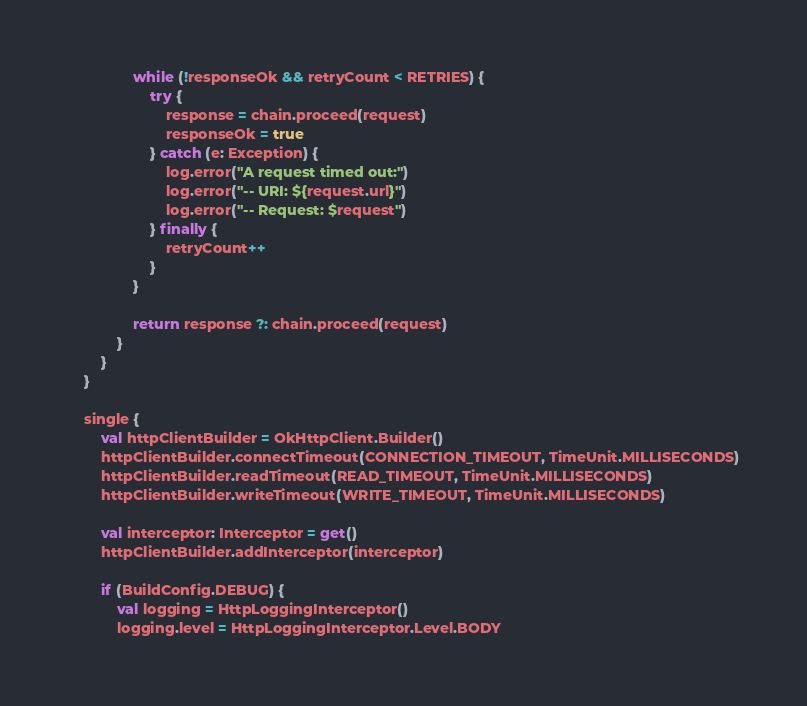<code> <loc_0><loc_0><loc_500><loc_500><_Kotlin_>                while (!responseOk && retryCount < RETRIES) {
                    try {
                        response = chain.proceed(request)
                        responseOk = true
                    } catch (e: Exception) {
                        log.error("A request timed out:")
                        log.error("-- URI: ${request.url}")
                        log.error("-- Request: $request")
                    } finally {
                        retryCount++
                    }
                }

                return response ?: chain.proceed(request)
            }
        }
    }

    single {
        val httpClientBuilder = OkHttpClient.Builder()
        httpClientBuilder.connectTimeout(CONNECTION_TIMEOUT, TimeUnit.MILLISECONDS)
        httpClientBuilder.readTimeout(READ_TIMEOUT, TimeUnit.MILLISECONDS)
        httpClientBuilder.writeTimeout(WRITE_TIMEOUT, TimeUnit.MILLISECONDS)

        val interceptor: Interceptor = get()
        httpClientBuilder.addInterceptor(interceptor)

        if (BuildConfig.DEBUG) {
            val logging = HttpLoggingInterceptor()
            logging.level = HttpLoggingInterceptor.Level.BODY</code> 